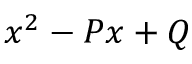Convert formula to latex. <formula><loc_0><loc_0><loc_500><loc_500>x ^ { 2 } - P x + Q</formula> 